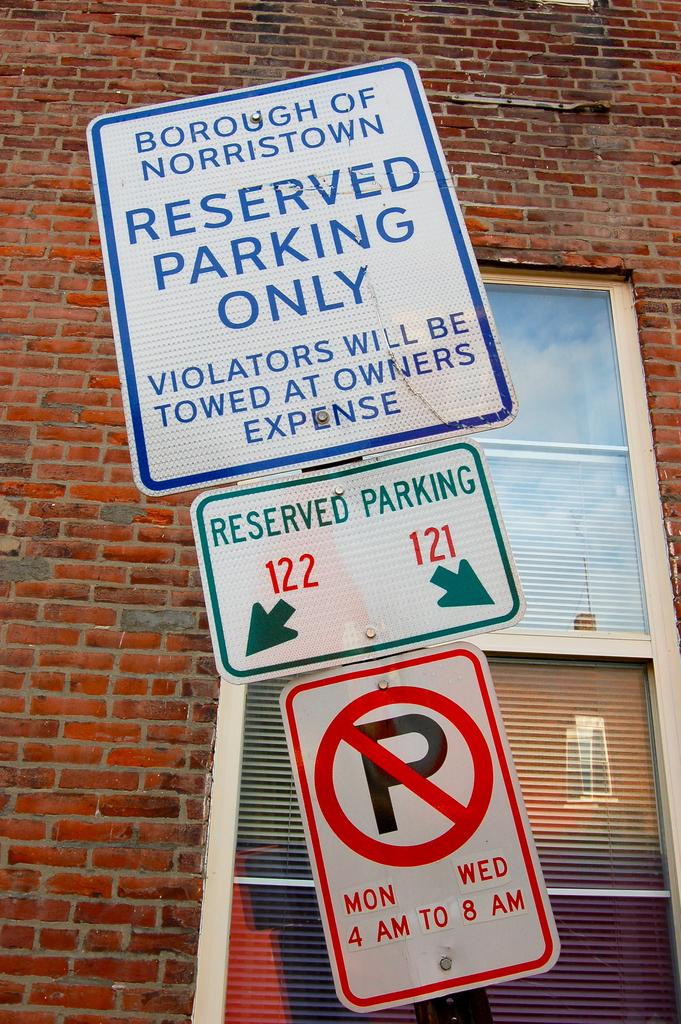<image>
Write a terse but informative summary of the picture. a no parking sign below a reserved parking sign 